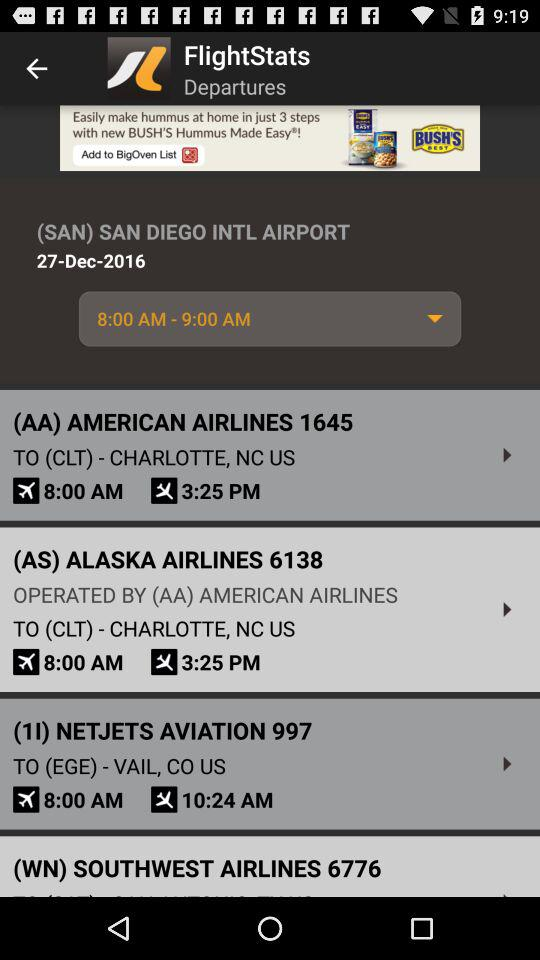Which airline has the number 1645? 1645 is the number of "AMERICAN AIRLINES". 